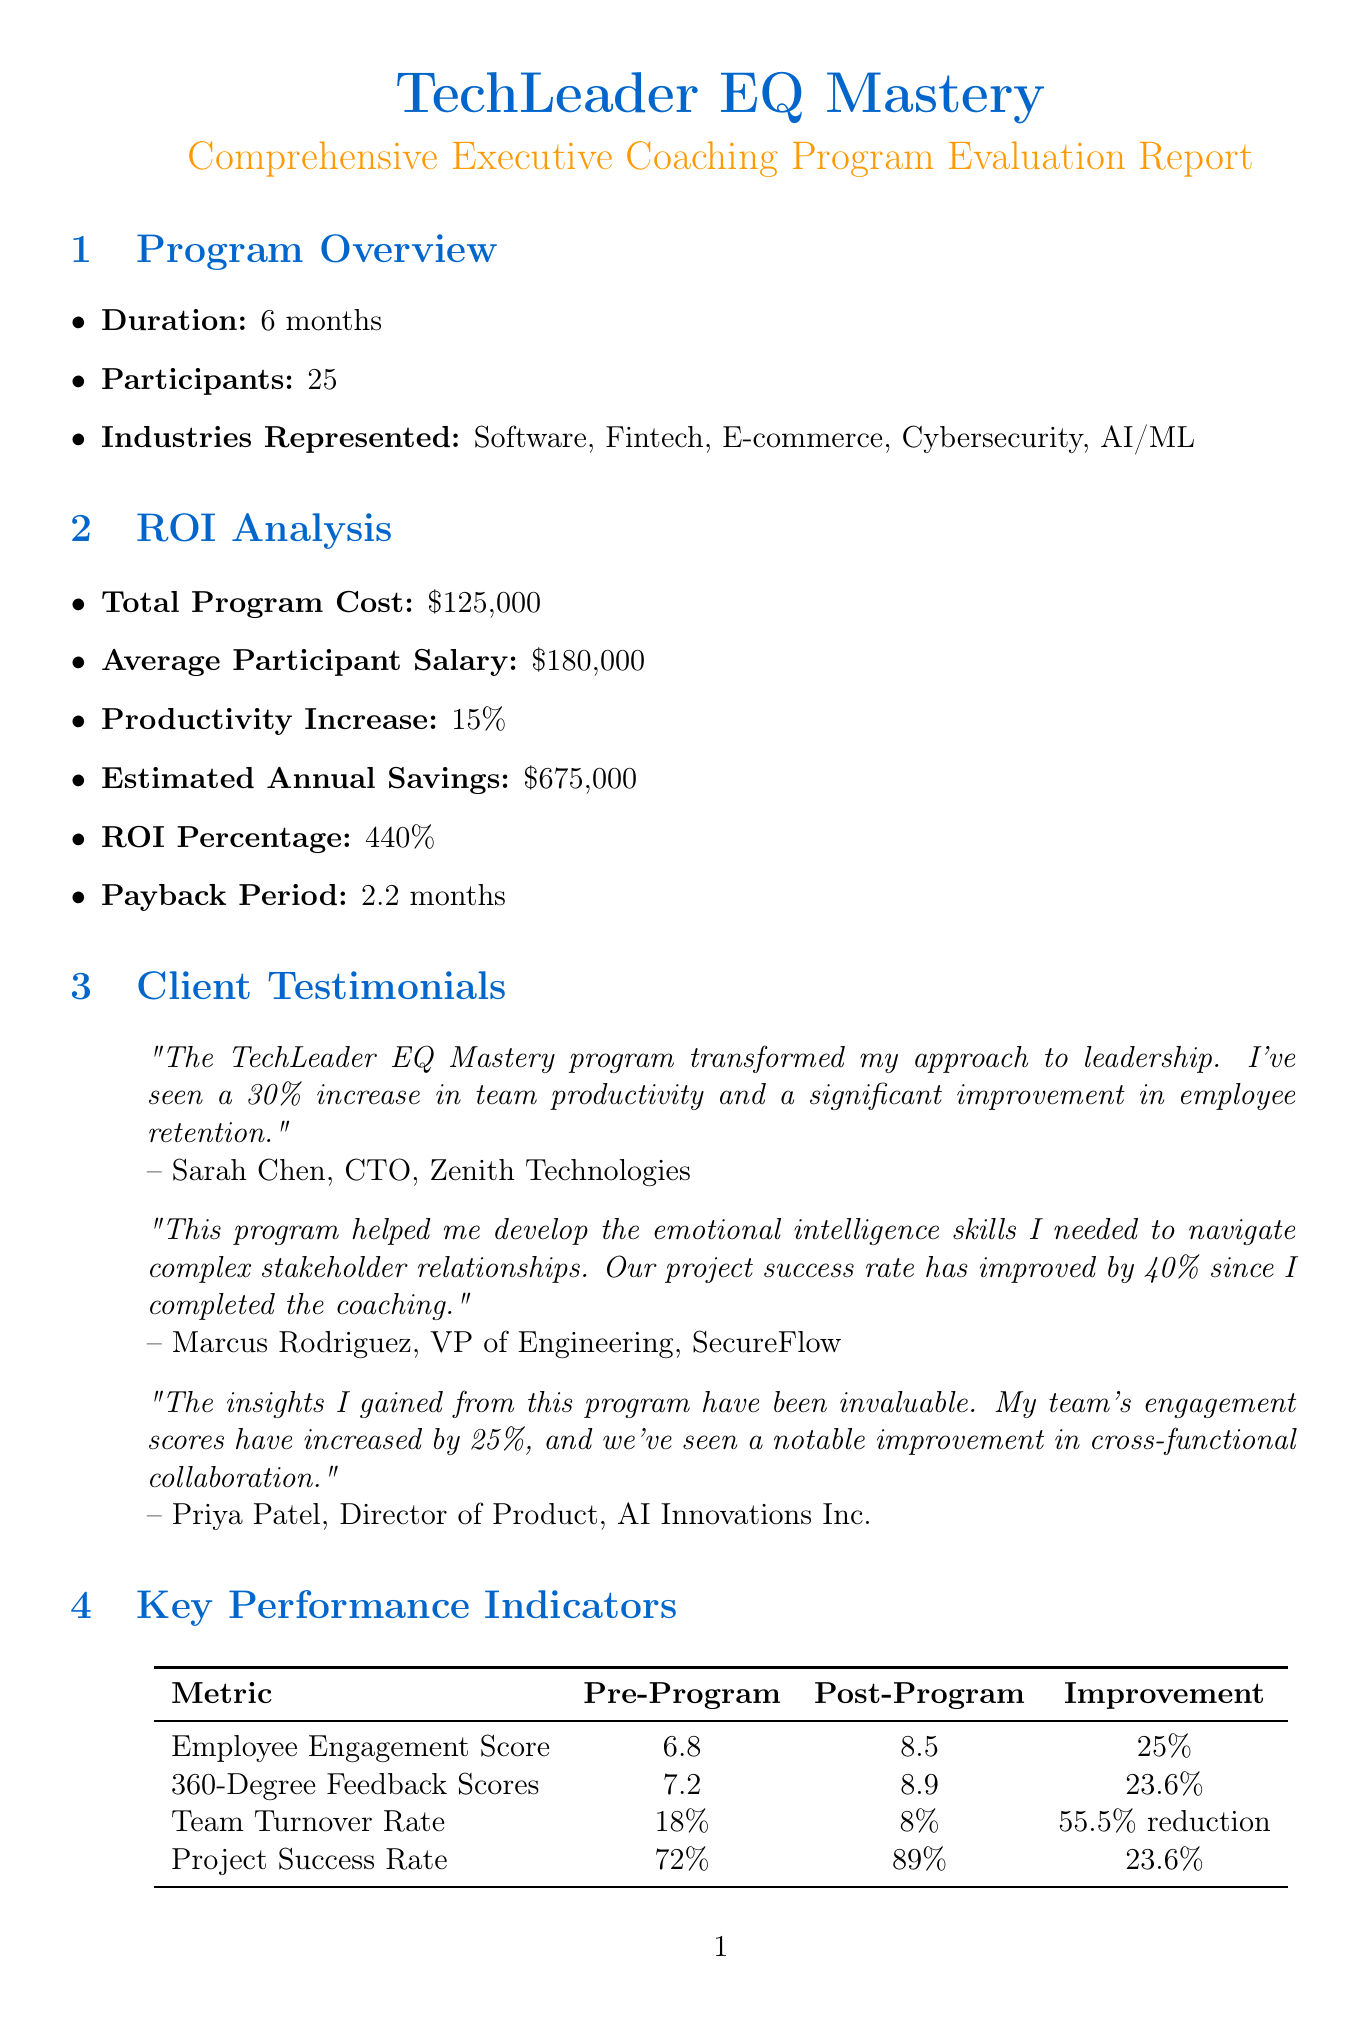What is the program duration? The program duration is specified in the overview section of the document as 6 months.
Answer: 6 months How many participants were in the program? The document states that there were 25 participants in the program overview section.
Answer: 25 What is the ROI percentage of the program? The ROI percentage can be found in the ROI analysis section, which shows an ROI percentage of 440%.
Answer: 440% Which industry had no representation in the program? The document lists the industries represented in the program but does not mention any unrepresented industry, thus requiring reasoning around the information to identify one, such as Healthcare.
Answer: Healthcare What was the improvement in employee engagement score? The key performance indicator section indicates a 25% improvement in the employee engagement score after the program.
Answer: 25% How long is each one-on-one coaching session? The program components describe that each one-on-one coaching session lasts for 90 minutes.
Answer: 90 minutes What was the average participant salary? The average participant salary is mentioned in the ROI analysis as $180,000.
Answer: $180,000 What specific feedback did Sarah Chen provide? The testimonial section includes Sarah Chen's statement about a 30% increase in team productivity due to the program.
Answer: 30% increase in team productivity What is one future recommendation for the program? The document lists several future recommendations, one of which is to implement a mentorship program for alumni.
Answer: Implement a mentorship program for program alumni 